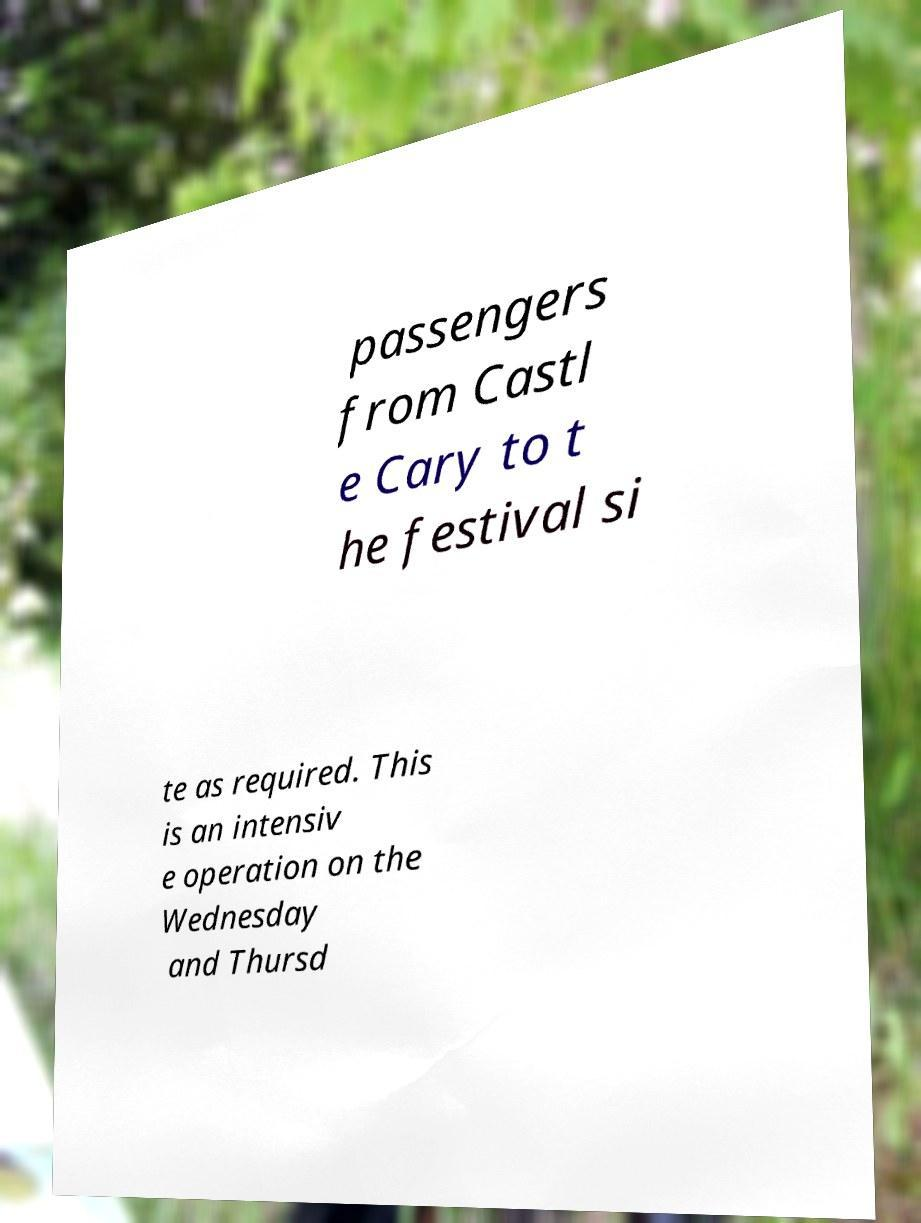What messages or text are displayed in this image? I need them in a readable, typed format. passengers from Castl e Cary to t he festival si te as required. This is an intensiv e operation on the Wednesday and Thursd 